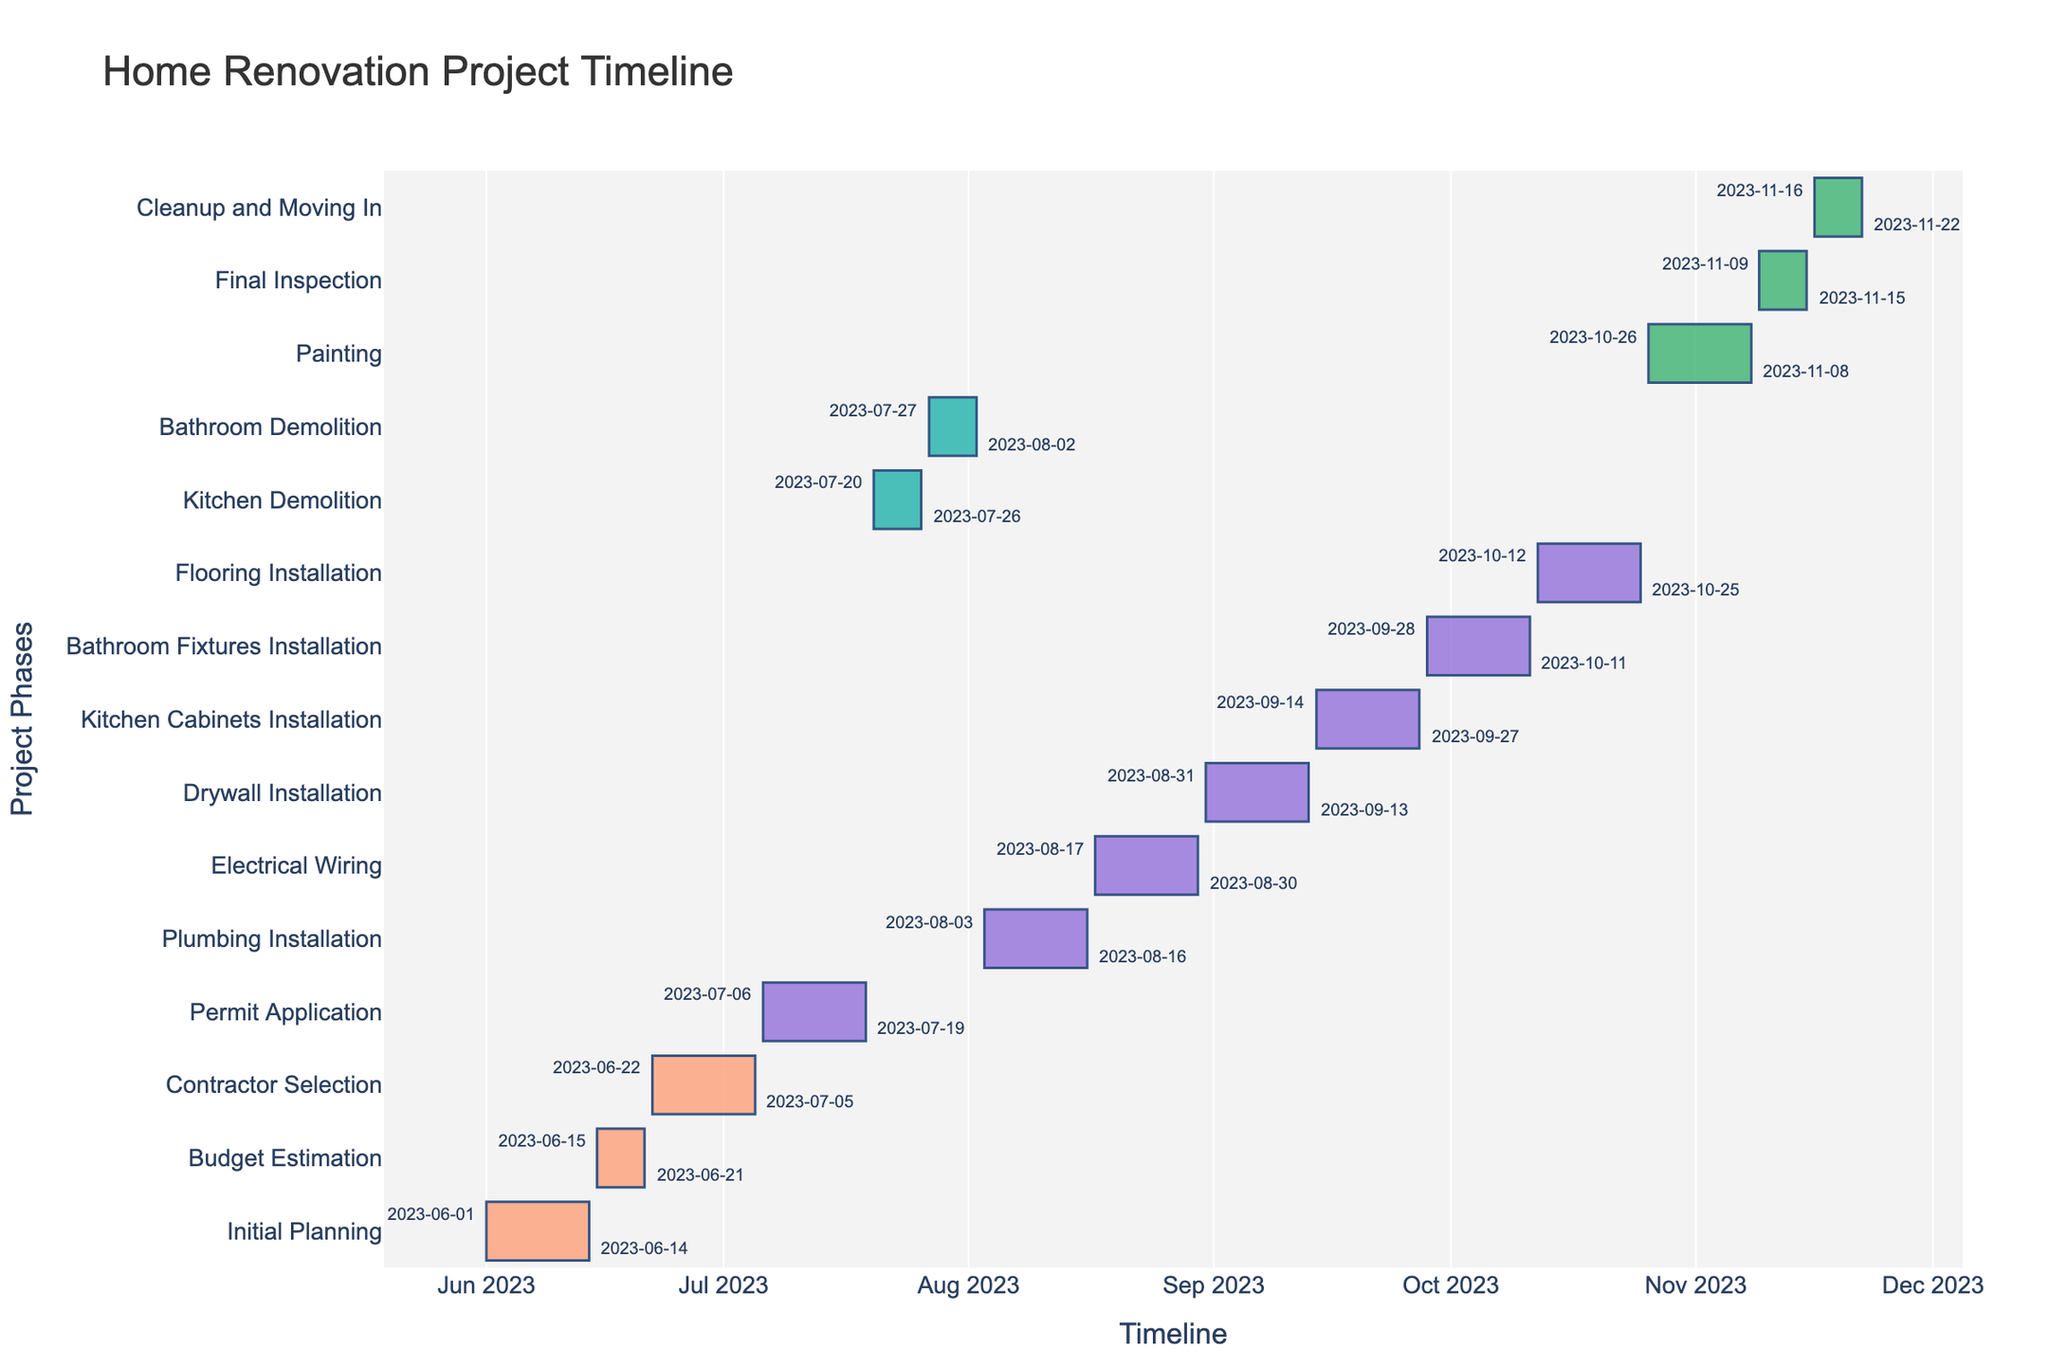What is the title of the chart? The title of the chart is usually displayed at the top center of the figure. In this case, it reads "Home Renovation Project Timeline".
Answer: Home Renovation Project Timeline What is the first task listed in the project timeline? The first task listed in the Gantt chart is placed at the top of the vertical axis (y-axis). Here, the first task is "Initial Planning".
Answer: Initial Planning Which task has the longest duration? To find the task with the longest duration, look at the length of the bars in the Gantt chart. The task "Painting" extends the longest from October 26, 2023, to November 8, 2023, spanning 14 days.
Answer: Painting When does the "Electrical Wiring" task start and end? The start and end dates are annotated near the corresponding task bar. For "Electrical Wiring," it starts on August 17, 2023, and ends on August 30, 2023.
Answer: August 17, 2023, and August 30, 2023 How many phases, categorized by color, are there in the chart? Colors categorize the phases. By examining the legend and the colors on the bars, there are four phases: Planning, Demolition, Installation, and Finishing.
Answer: Four Which tasks fall under the "Demolition" phase? Tasks under the "Demolition" phase are colored the same. The tasks "Kitchen Demolition" and "Bathroom Demolition" share the same color and are thus part of the Demolition phase.
Answer: Kitchen Demolition, Bathroom Demolition Between the "Initial Planning" and "Permit Application" tasks, which one takes longer? Subtract the start date from the end date for both tasks. "Initial Planning" (June 1 to June 14) spans 14 days, while "Permit Application" (July 6 to July 19) spans 14 days. Both tasks take the same duration.
Answer: Same duration Which tasks are completed by the end of September 2023? Tasks with end dates annotated on or before September 30, 2023. Tasks up to "Kitchen Cabinets Installation," ending on September 27, 2023, are completed by then.
Answer: Initial Planning, Budget Estimation, Contractor Selection, Permit Application, Kitchen Demolition, Bathroom Demolition, Plumbing Installation, Electrical Wiring, Drywall Installation, Kitchen Cabinets Installation How many tasks are within the "Installation" phase? Tasks under the "Installation" phase share the same specific color. There are five tasks: "Plumbing Installation," "Electrical Wiring," "Drywall Installation," "Kitchen Cabinets Installation," and "Bathroom Fixtures Installation."
Answer: Five What is the total duration for the "Finishing" phase activities? Sum the duration of each "Finishing" phase task. "Painting" (14 days), "Final Inspection" (7 days), and "Cleanup and Moving In" (7 days) together are 14 + 7 + 7 = 28 days.
Answer: 28 days 